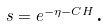Convert formula to latex. <formula><loc_0><loc_0><loc_500><loc_500>s = e ^ { - \eta - C H } \text {.}</formula> 